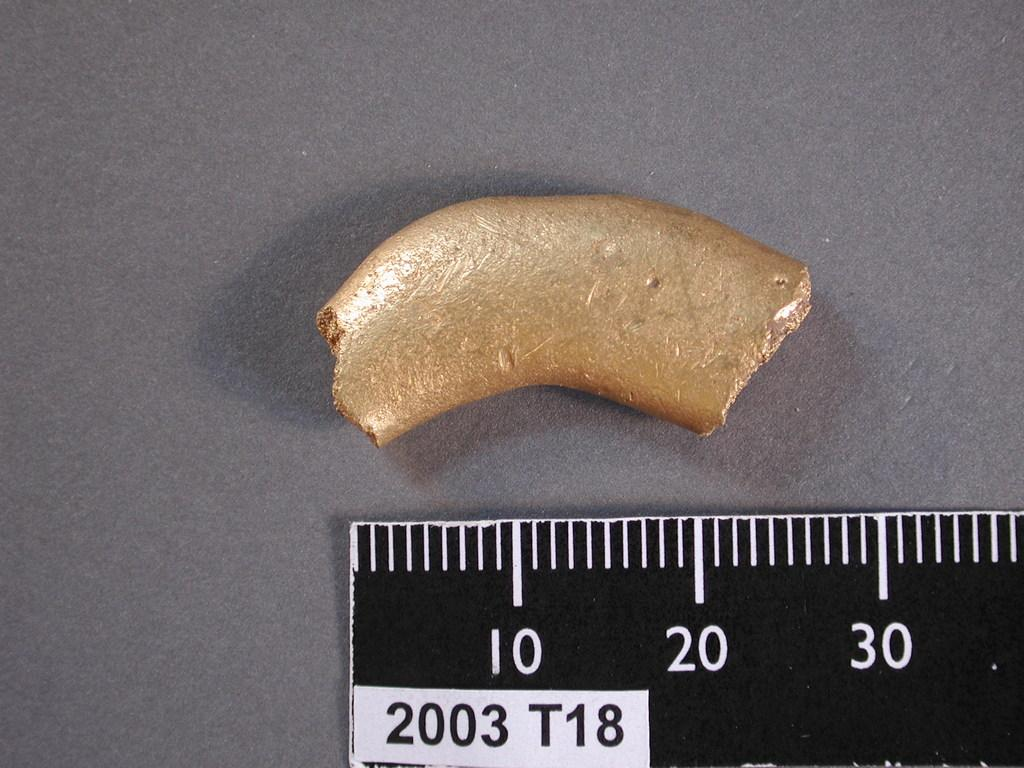<image>
Offer a succinct explanation of the picture presented. the year 2003 is on the ruler that is black 